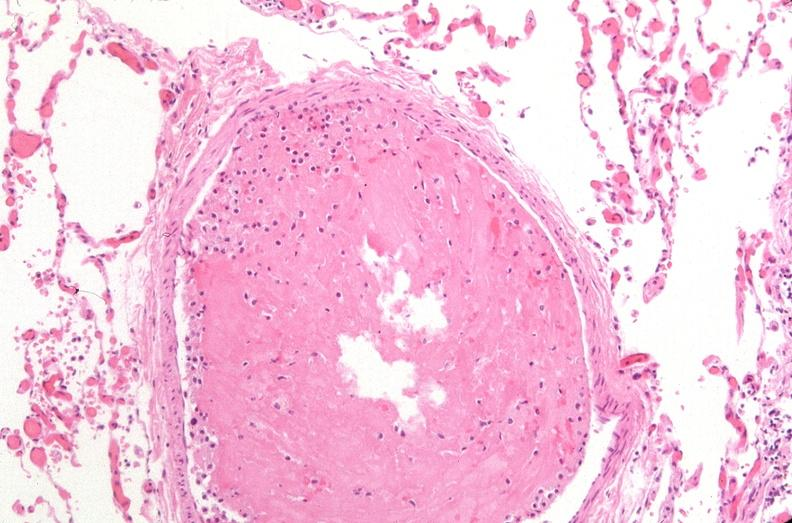s respiratory present?
Answer the question using a single word or phrase. Yes 